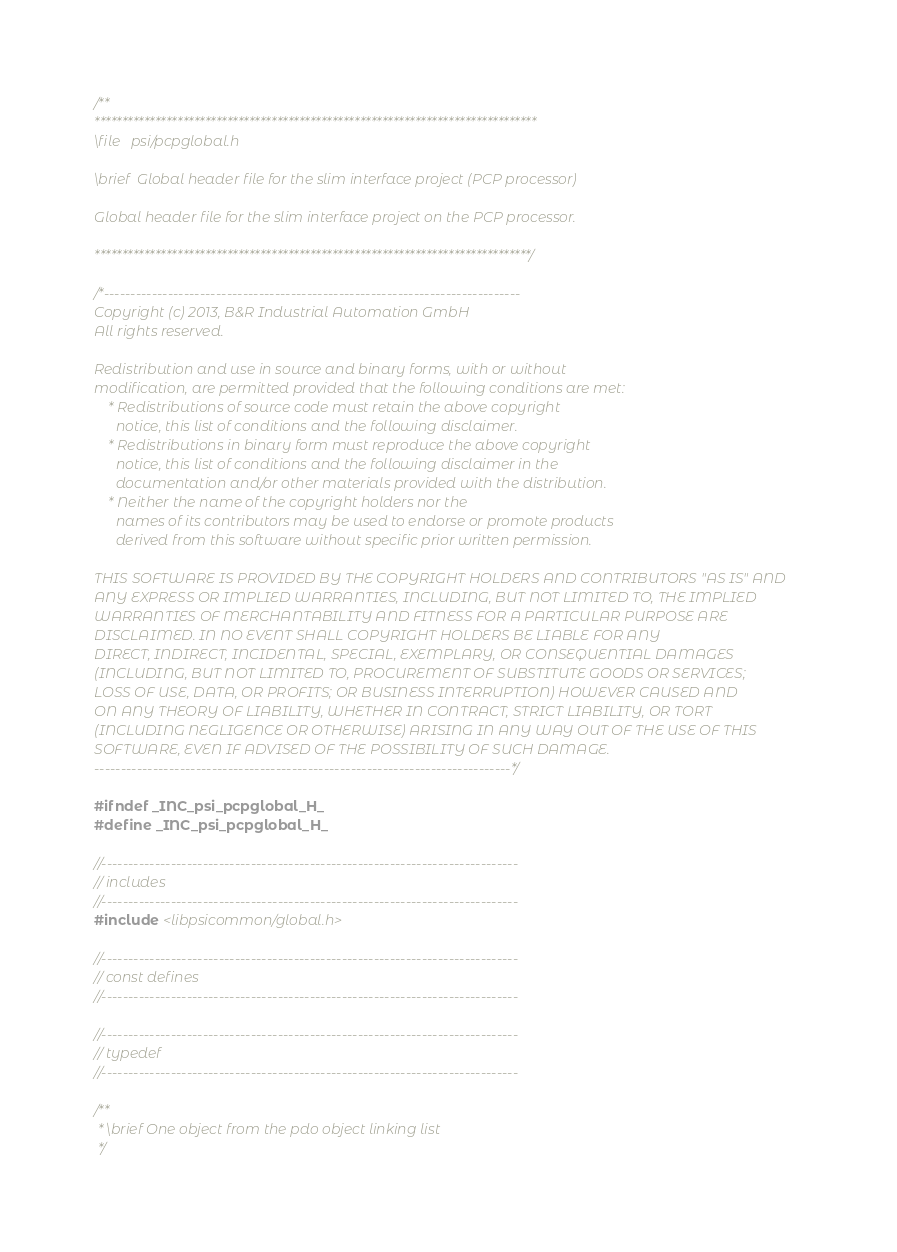Convert code to text. <code><loc_0><loc_0><loc_500><loc_500><_C_>/**
********************************************************************************
\file   psi/pcpglobal.h

\brief  Global header file for the slim interface project (PCP processor)

Global header file for the slim interface project on the PCP processor.

*******************************************************************************/

/*------------------------------------------------------------------------------
Copyright (c) 2013, B&R Industrial Automation GmbH
All rights reserved.

Redistribution and use in source and binary forms, with or without
modification, are permitted provided that the following conditions are met:
    * Redistributions of source code must retain the above copyright
      notice, this list of conditions and the following disclaimer.
    * Redistributions in binary form must reproduce the above copyright
      notice, this list of conditions and the following disclaimer in the
      documentation and/or other materials provided with the distribution.
    * Neither the name of the copyright holders nor the
      names of its contributors may be used to endorse or promote products
      derived from this software without specific prior written permission.

THIS SOFTWARE IS PROVIDED BY THE COPYRIGHT HOLDERS AND CONTRIBUTORS "AS IS" AND
ANY EXPRESS OR IMPLIED WARRANTIES, INCLUDING, BUT NOT LIMITED TO, THE IMPLIED
WARRANTIES OF MERCHANTABILITY AND FITNESS FOR A PARTICULAR PURPOSE ARE
DISCLAIMED. IN NO EVENT SHALL COPYRIGHT HOLDERS BE LIABLE FOR ANY
DIRECT, INDIRECT, INCIDENTAL, SPECIAL, EXEMPLARY, OR CONSEQUENTIAL DAMAGES
(INCLUDING, BUT NOT LIMITED TO, PROCUREMENT OF SUBSTITUTE GOODS OR SERVICES;
LOSS OF USE, DATA, OR PROFITS; OR BUSINESS INTERRUPTION) HOWEVER CAUSED AND
ON ANY THEORY OF LIABILITY, WHETHER IN CONTRACT, STRICT LIABILITY, OR TORT
(INCLUDING NEGLIGENCE OR OTHERWISE) ARISING IN ANY WAY OUT OF THE USE OF THIS
SOFTWARE, EVEN IF ADVISED OF THE POSSIBILITY OF SUCH DAMAGE.
------------------------------------------------------------------------------*/

#ifndef _INC_psi_pcpglobal_H_
#define _INC_psi_pcpglobal_H_

//------------------------------------------------------------------------------
// includes
//------------------------------------------------------------------------------
#include <libpsicommon/global.h>

//------------------------------------------------------------------------------
// const defines
//------------------------------------------------------------------------------

//------------------------------------------------------------------------------
// typedef
//------------------------------------------------------------------------------

/**
 * \brief One object from the pdo object linking list
 */</code> 